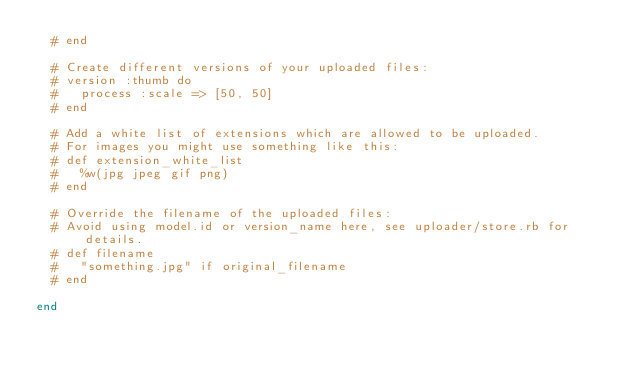<code> <loc_0><loc_0><loc_500><loc_500><_Ruby_>  # end

  # Create different versions of your uploaded files:
  # version :thumb do
  #   process :scale => [50, 50]
  # end

  # Add a white list of extensions which are allowed to be uploaded.
  # For images you might use something like this:
  # def extension_white_list
  #   %w(jpg jpeg gif png)
  # end

  # Override the filename of the uploaded files:
  # Avoid using model.id or version_name here, see uploader/store.rb for details.
  # def filename
  #   "something.jpg" if original_filename
  # end

end
</code> 